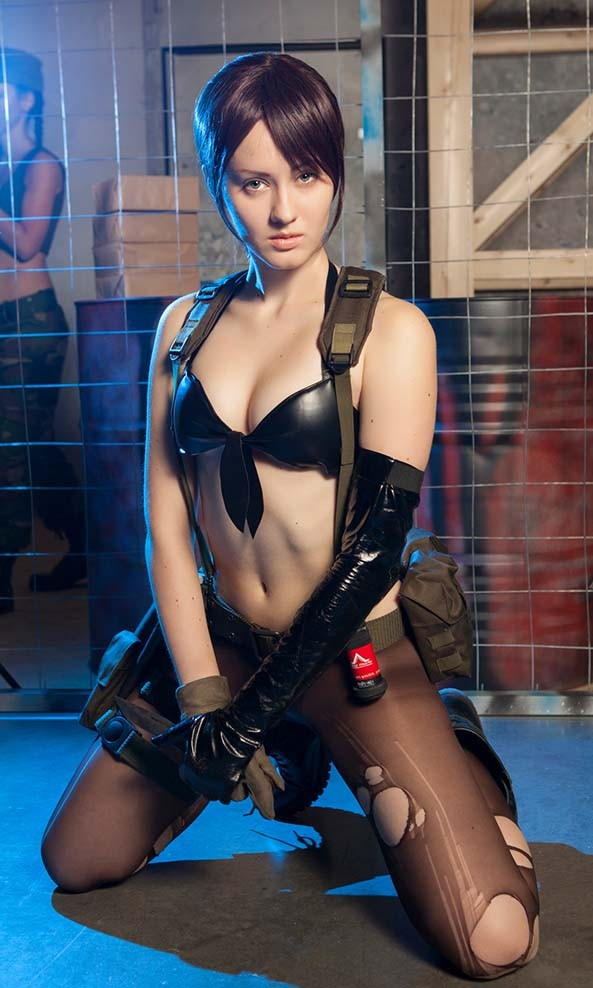What is the significance of the red emblem on the glove, and how might it relate to the character's identity or backstory? The red emblem on the glove is distinctive and appears to be a triangular symbol with a red background and a white element at the center, resembling a stylized "A" or a peak. In the context of cosplay, such details are often significant and can represent the character's affiliation, rank, group, or special abilities within the source material's universe. Without specific knowledge of the character's origin, one can infer that the emblem denotes a special status or membership in a particular group or organization within the narrative from which the character is drawn. The emblem's prominent placement on the glove indicates its importance to the character's identity. 